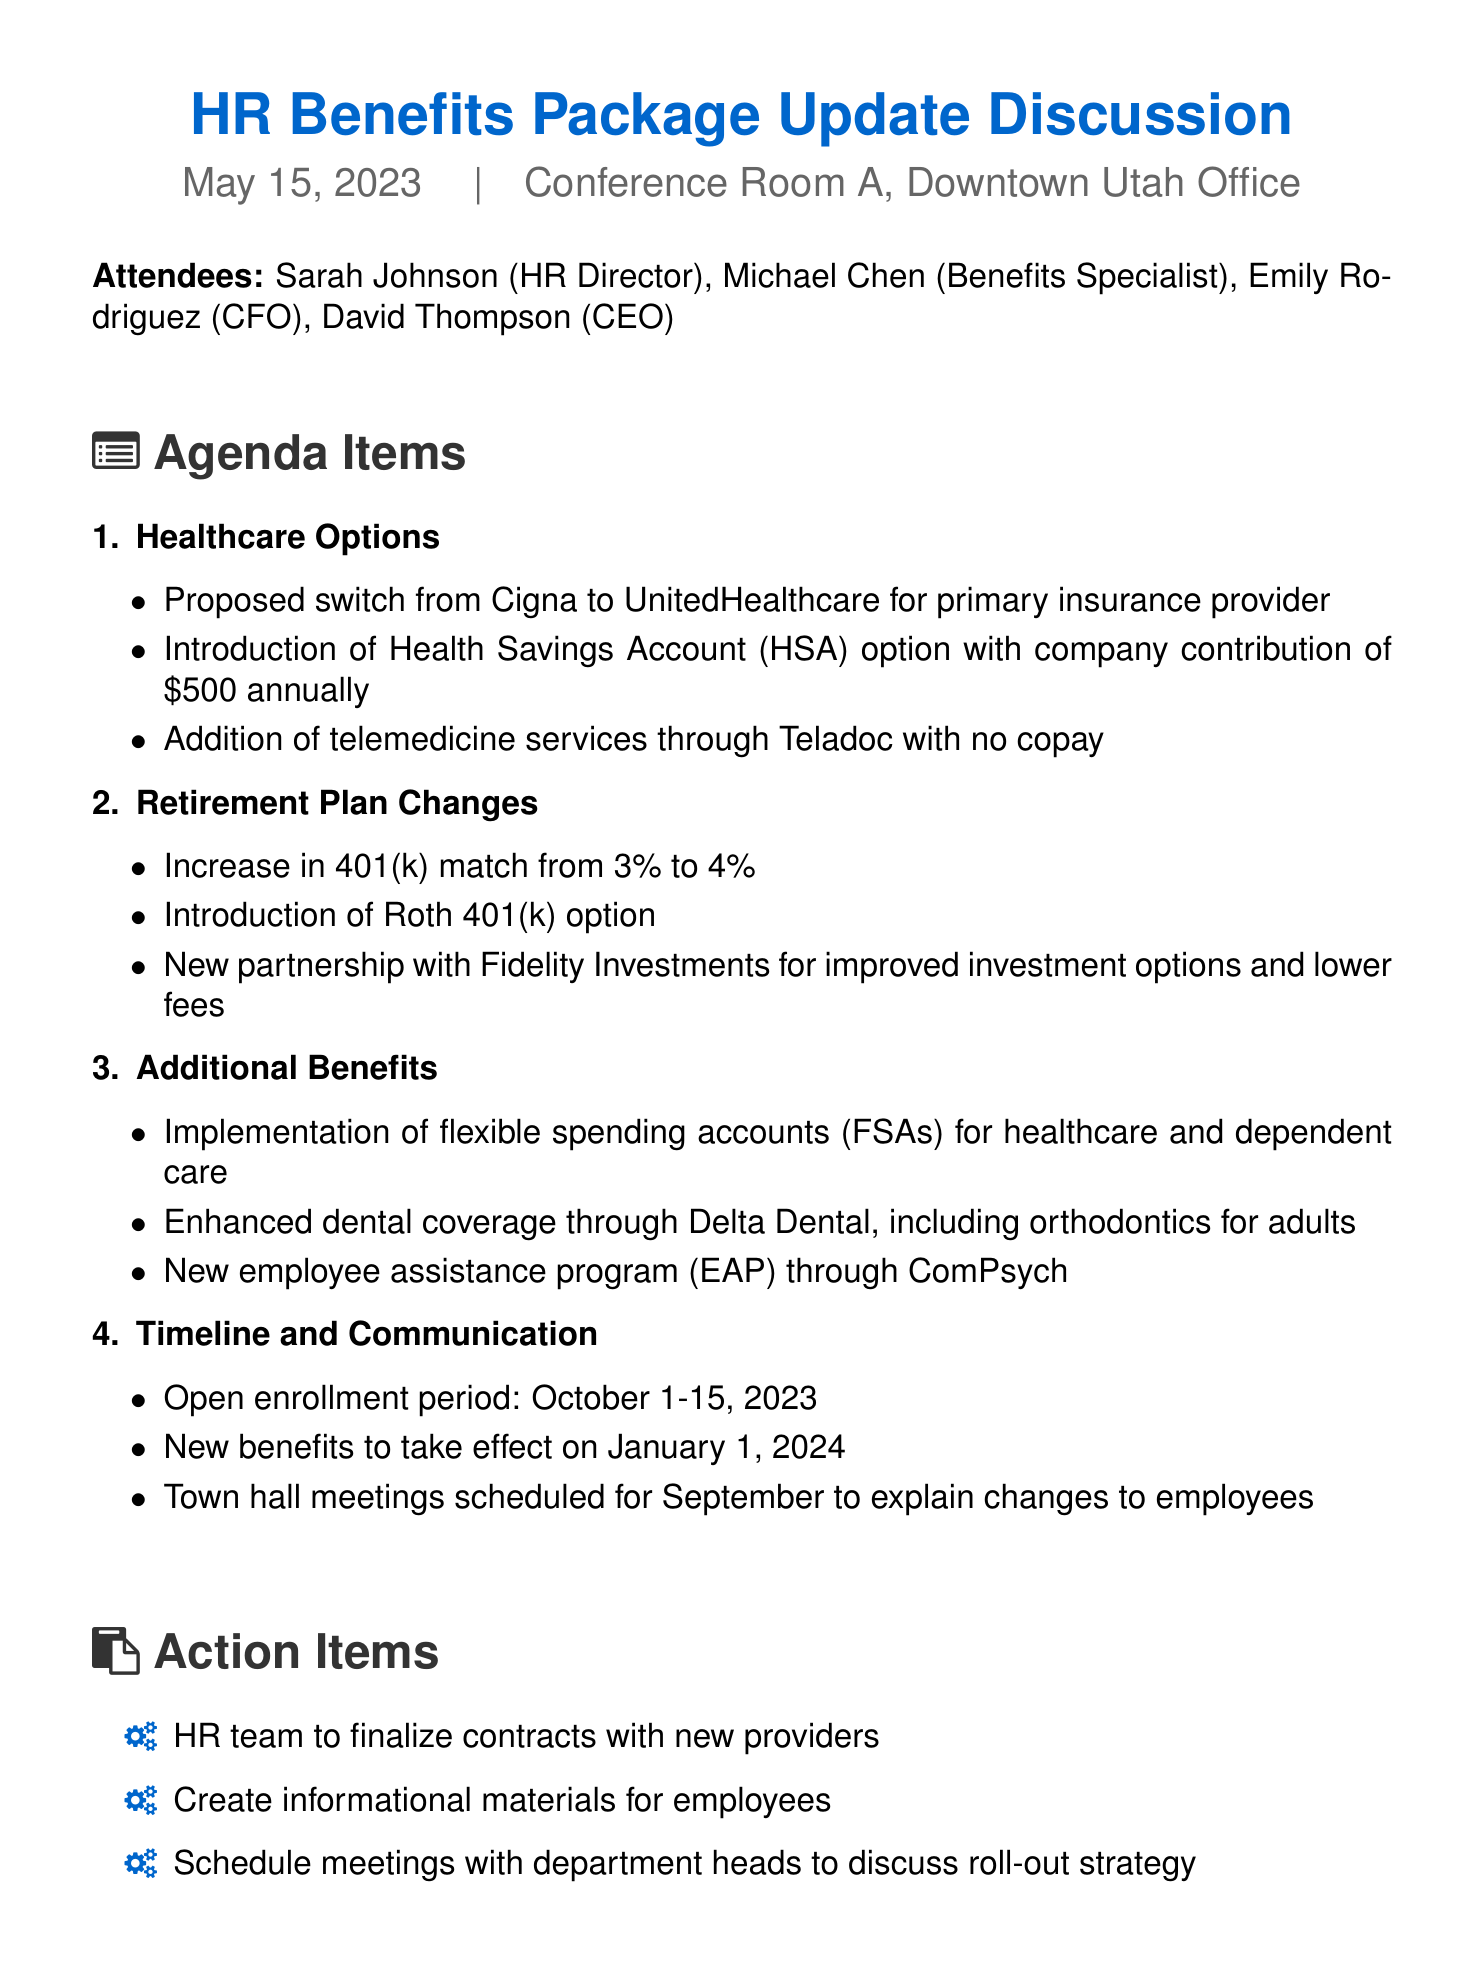What is the date of the meeting? The date of the meeting is mentioned in the document as May 15, 2023.
Answer: May 15, 2023 Who proposed the switch to UnitedHealthcare? The document indicates that the proposed switch is discussed by the team, but it does not specify a single individual. However, it is part of the agenda led by the HR team.
Answer: HR team What is the new annual contribution for the Health Savings Account? The document details the annual company contribution to the Health Savings Account is $500.
Answer: $500 What percentage is the increase in the 401(k) match? The document states that the increase in the 401(k) match is from 3% to 4%, which indicates an increase of 1%.
Answer: 1 percent When is the open enrollment period scheduled? According to the document, the open enrollment period is from October 1 to October 15, 2023.
Answer: October 1-15, 2023 What are the enhanced dental coverage benefits? The document mentions enhanced dental coverage includes orthodontics for adults as part of the additional benefits.
Answer: Orthodontics for adults What is the purpose of the town hall meetings scheduled for September? The meetings are scheduled to explain changes to employees regarding the benefits package updates.
Answer: Explain changes to employees Who is responsible for creating informational materials for employees? The action item specifies that the HR team has the responsibility to create informational materials.
Answer: HR team What is the primary topic of the first agenda item? The first agenda item covers Healthcare Options, which includes various proposed benefits.
Answer: Healthcare Options 